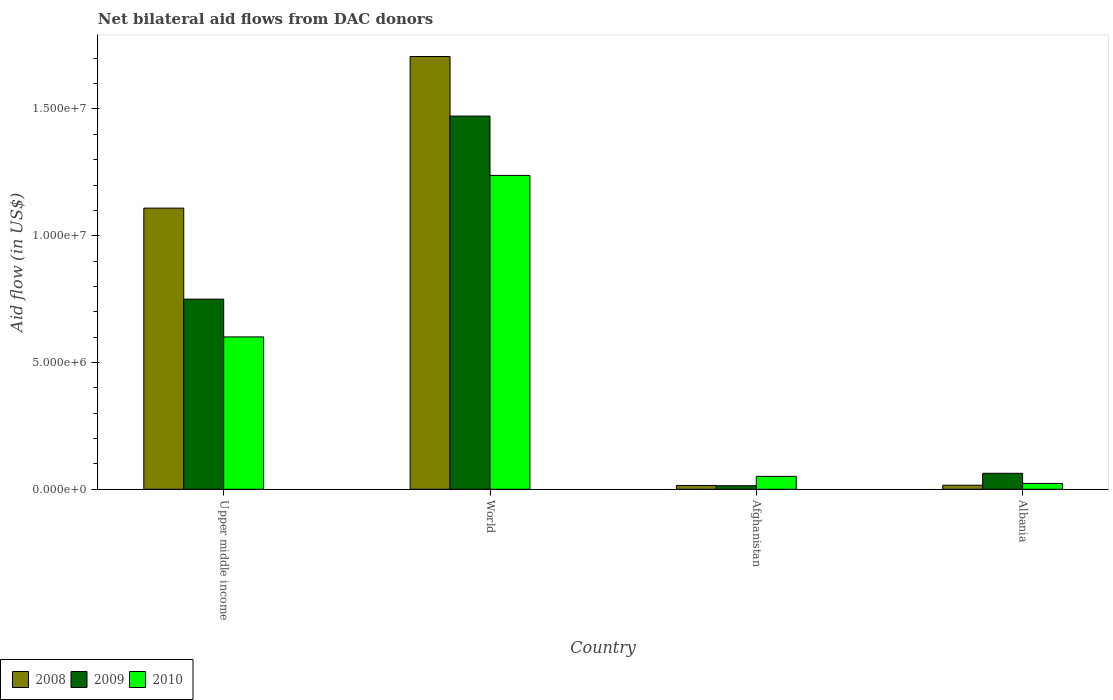How many different coloured bars are there?
Offer a terse response. 3. Are the number of bars per tick equal to the number of legend labels?
Your answer should be very brief. Yes. Are the number of bars on each tick of the X-axis equal?
Offer a very short reply. Yes. How many bars are there on the 2nd tick from the right?
Ensure brevity in your answer.  3. What is the label of the 4th group of bars from the left?
Give a very brief answer. Albania. What is the net bilateral aid flow in 2010 in Upper middle income?
Keep it short and to the point. 6.01e+06. Across all countries, what is the maximum net bilateral aid flow in 2010?
Your response must be concise. 1.24e+07. Across all countries, what is the minimum net bilateral aid flow in 2008?
Make the answer very short. 1.50e+05. In which country was the net bilateral aid flow in 2010 maximum?
Offer a very short reply. World. In which country was the net bilateral aid flow in 2010 minimum?
Provide a short and direct response. Albania. What is the total net bilateral aid flow in 2010 in the graph?
Provide a short and direct response. 1.91e+07. What is the difference between the net bilateral aid flow in 2008 in Afghanistan and that in Upper middle income?
Give a very brief answer. -1.09e+07. What is the difference between the net bilateral aid flow in 2010 in Albania and the net bilateral aid flow in 2009 in Upper middle income?
Provide a short and direct response. -7.27e+06. What is the average net bilateral aid flow in 2009 per country?
Make the answer very short. 5.75e+06. What is the difference between the net bilateral aid flow of/in 2010 and net bilateral aid flow of/in 2008 in World?
Provide a short and direct response. -4.69e+06. What is the ratio of the net bilateral aid flow in 2009 in Albania to that in Upper middle income?
Offer a terse response. 0.08. Is the net bilateral aid flow in 2008 in Afghanistan less than that in Upper middle income?
Keep it short and to the point. Yes. What is the difference between the highest and the second highest net bilateral aid flow in 2008?
Offer a very short reply. 1.69e+07. What is the difference between the highest and the lowest net bilateral aid flow in 2010?
Your answer should be very brief. 1.22e+07. In how many countries, is the net bilateral aid flow in 2009 greater than the average net bilateral aid flow in 2009 taken over all countries?
Ensure brevity in your answer.  2. What does the 3rd bar from the right in World represents?
Make the answer very short. 2008. Is it the case that in every country, the sum of the net bilateral aid flow in 2009 and net bilateral aid flow in 2008 is greater than the net bilateral aid flow in 2010?
Keep it short and to the point. No. Does the graph contain grids?
Your response must be concise. No. What is the title of the graph?
Your answer should be very brief. Net bilateral aid flows from DAC donors. What is the label or title of the X-axis?
Provide a succinct answer. Country. What is the label or title of the Y-axis?
Your response must be concise. Aid flow (in US$). What is the Aid flow (in US$) in 2008 in Upper middle income?
Make the answer very short. 1.11e+07. What is the Aid flow (in US$) in 2009 in Upper middle income?
Give a very brief answer. 7.50e+06. What is the Aid flow (in US$) of 2010 in Upper middle income?
Provide a succinct answer. 6.01e+06. What is the Aid flow (in US$) of 2008 in World?
Your answer should be compact. 1.71e+07. What is the Aid flow (in US$) in 2009 in World?
Your answer should be very brief. 1.47e+07. What is the Aid flow (in US$) of 2010 in World?
Your response must be concise. 1.24e+07. What is the Aid flow (in US$) in 2010 in Afghanistan?
Provide a succinct answer. 5.10e+05. What is the Aid flow (in US$) of 2009 in Albania?
Provide a succinct answer. 6.30e+05. Across all countries, what is the maximum Aid flow (in US$) of 2008?
Provide a succinct answer. 1.71e+07. Across all countries, what is the maximum Aid flow (in US$) of 2009?
Your response must be concise. 1.47e+07. Across all countries, what is the maximum Aid flow (in US$) of 2010?
Keep it short and to the point. 1.24e+07. Across all countries, what is the minimum Aid flow (in US$) of 2008?
Make the answer very short. 1.50e+05. Across all countries, what is the minimum Aid flow (in US$) in 2009?
Provide a short and direct response. 1.40e+05. Across all countries, what is the minimum Aid flow (in US$) of 2010?
Your answer should be compact. 2.30e+05. What is the total Aid flow (in US$) of 2008 in the graph?
Your answer should be compact. 2.85e+07. What is the total Aid flow (in US$) of 2009 in the graph?
Your answer should be compact. 2.30e+07. What is the total Aid flow (in US$) of 2010 in the graph?
Make the answer very short. 1.91e+07. What is the difference between the Aid flow (in US$) in 2008 in Upper middle income and that in World?
Provide a succinct answer. -5.98e+06. What is the difference between the Aid flow (in US$) in 2009 in Upper middle income and that in World?
Provide a short and direct response. -7.22e+06. What is the difference between the Aid flow (in US$) in 2010 in Upper middle income and that in World?
Offer a terse response. -6.37e+06. What is the difference between the Aid flow (in US$) of 2008 in Upper middle income and that in Afghanistan?
Offer a very short reply. 1.09e+07. What is the difference between the Aid flow (in US$) of 2009 in Upper middle income and that in Afghanistan?
Make the answer very short. 7.36e+06. What is the difference between the Aid flow (in US$) of 2010 in Upper middle income and that in Afghanistan?
Provide a short and direct response. 5.50e+06. What is the difference between the Aid flow (in US$) of 2008 in Upper middle income and that in Albania?
Ensure brevity in your answer.  1.09e+07. What is the difference between the Aid flow (in US$) in 2009 in Upper middle income and that in Albania?
Your answer should be compact. 6.87e+06. What is the difference between the Aid flow (in US$) of 2010 in Upper middle income and that in Albania?
Your answer should be very brief. 5.78e+06. What is the difference between the Aid flow (in US$) of 2008 in World and that in Afghanistan?
Your answer should be compact. 1.69e+07. What is the difference between the Aid flow (in US$) of 2009 in World and that in Afghanistan?
Provide a short and direct response. 1.46e+07. What is the difference between the Aid flow (in US$) in 2010 in World and that in Afghanistan?
Offer a terse response. 1.19e+07. What is the difference between the Aid flow (in US$) of 2008 in World and that in Albania?
Your response must be concise. 1.69e+07. What is the difference between the Aid flow (in US$) of 2009 in World and that in Albania?
Offer a terse response. 1.41e+07. What is the difference between the Aid flow (in US$) in 2010 in World and that in Albania?
Make the answer very short. 1.22e+07. What is the difference between the Aid flow (in US$) in 2008 in Afghanistan and that in Albania?
Your response must be concise. -10000. What is the difference between the Aid flow (in US$) in 2009 in Afghanistan and that in Albania?
Your answer should be very brief. -4.90e+05. What is the difference between the Aid flow (in US$) of 2010 in Afghanistan and that in Albania?
Your answer should be compact. 2.80e+05. What is the difference between the Aid flow (in US$) in 2008 in Upper middle income and the Aid flow (in US$) in 2009 in World?
Offer a terse response. -3.63e+06. What is the difference between the Aid flow (in US$) of 2008 in Upper middle income and the Aid flow (in US$) of 2010 in World?
Offer a very short reply. -1.29e+06. What is the difference between the Aid flow (in US$) in 2009 in Upper middle income and the Aid flow (in US$) in 2010 in World?
Provide a short and direct response. -4.88e+06. What is the difference between the Aid flow (in US$) of 2008 in Upper middle income and the Aid flow (in US$) of 2009 in Afghanistan?
Make the answer very short. 1.10e+07. What is the difference between the Aid flow (in US$) in 2008 in Upper middle income and the Aid flow (in US$) in 2010 in Afghanistan?
Keep it short and to the point. 1.06e+07. What is the difference between the Aid flow (in US$) of 2009 in Upper middle income and the Aid flow (in US$) of 2010 in Afghanistan?
Your response must be concise. 6.99e+06. What is the difference between the Aid flow (in US$) of 2008 in Upper middle income and the Aid flow (in US$) of 2009 in Albania?
Your answer should be compact. 1.05e+07. What is the difference between the Aid flow (in US$) in 2008 in Upper middle income and the Aid flow (in US$) in 2010 in Albania?
Provide a short and direct response. 1.09e+07. What is the difference between the Aid flow (in US$) in 2009 in Upper middle income and the Aid flow (in US$) in 2010 in Albania?
Provide a short and direct response. 7.27e+06. What is the difference between the Aid flow (in US$) of 2008 in World and the Aid flow (in US$) of 2009 in Afghanistan?
Your answer should be very brief. 1.69e+07. What is the difference between the Aid flow (in US$) of 2008 in World and the Aid flow (in US$) of 2010 in Afghanistan?
Your answer should be very brief. 1.66e+07. What is the difference between the Aid flow (in US$) in 2009 in World and the Aid flow (in US$) in 2010 in Afghanistan?
Provide a short and direct response. 1.42e+07. What is the difference between the Aid flow (in US$) in 2008 in World and the Aid flow (in US$) in 2009 in Albania?
Your answer should be very brief. 1.64e+07. What is the difference between the Aid flow (in US$) in 2008 in World and the Aid flow (in US$) in 2010 in Albania?
Provide a short and direct response. 1.68e+07. What is the difference between the Aid flow (in US$) of 2009 in World and the Aid flow (in US$) of 2010 in Albania?
Provide a succinct answer. 1.45e+07. What is the difference between the Aid flow (in US$) of 2008 in Afghanistan and the Aid flow (in US$) of 2009 in Albania?
Provide a succinct answer. -4.80e+05. What is the difference between the Aid flow (in US$) of 2008 in Afghanistan and the Aid flow (in US$) of 2010 in Albania?
Your response must be concise. -8.00e+04. What is the difference between the Aid flow (in US$) of 2009 in Afghanistan and the Aid flow (in US$) of 2010 in Albania?
Ensure brevity in your answer.  -9.00e+04. What is the average Aid flow (in US$) in 2008 per country?
Provide a succinct answer. 7.12e+06. What is the average Aid flow (in US$) in 2009 per country?
Make the answer very short. 5.75e+06. What is the average Aid flow (in US$) in 2010 per country?
Your answer should be very brief. 4.78e+06. What is the difference between the Aid flow (in US$) of 2008 and Aid flow (in US$) of 2009 in Upper middle income?
Provide a succinct answer. 3.59e+06. What is the difference between the Aid flow (in US$) in 2008 and Aid flow (in US$) in 2010 in Upper middle income?
Give a very brief answer. 5.08e+06. What is the difference between the Aid flow (in US$) in 2009 and Aid flow (in US$) in 2010 in Upper middle income?
Your answer should be very brief. 1.49e+06. What is the difference between the Aid flow (in US$) in 2008 and Aid flow (in US$) in 2009 in World?
Offer a terse response. 2.35e+06. What is the difference between the Aid flow (in US$) of 2008 and Aid flow (in US$) of 2010 in World?
Give a very brief answer. 4.69e+06. What is the difference between the Aid flow (in US$) of 2009 and Aid flow (in US$) of 2010 in World?
Offer a very short reply. 2.34e+06. What is the difference between the Aid flow (in US$) in 2008 and Aid flow (in US$) in 2009 in Afghanistan?
Your response must be concise. 10000. What is the difference between the Aid flow (in US$) of 2008 and Aid flow (in US$) of 2010 in Afghanistan?
Give a very brief answer. -3.60e+05. What is the difference between the Aid flow (in US$) in 2009 and Aid flow (in US$) in 2010 in Afghanistan?
Provide a short and direct response. -3.70e+05. What is the difference between the Aid flow (in US$) of 2008 and Aid flow (in US$) of 2009 in Albania?
Offer a terse response. -4.70e+05. What is the difference between the Aid flow (in US$) in 2008 and Aid flow (in US$) in 2010 in Albania?
Make the answer very short. -7.00e+04. What is the difference between the Aid flow (in US$) of 2009 and Aid flow (in US$) of 2010 in Albania?
Ensure brevity in your answer.  4.00e+05. What is the ratio of the Aid flow (in US$) in 2008 in Upper middle income to that in World?
Your answer should be compact. 0.65. What is the ratio of the Aid flow (in US$) in 2009 in Upper middle income to that in World?
Ensure brevity in your answer.  0.51. What is the ratio of the Aid flow (in US$) in 2010 in Upper middle income to that in World?
Provide a succinct answer. 0.49. What is the ratio of the Aid flow (in US$) in 2008 in Upper middle income to that in Afghanistan?
Your response must be concise. 73.93. What is the ratio of the Aid flow (in US$) of 2009 in Upper middle income to that in Afghanistan?
Offer a terse response. 53.57. What is the ratio of the Aid flow (in US$) of 2010 in Upper middle income to that in Afghanistan?
Give a very brief answer. 11.78. What is the ratio of the Aid flow (in US$) in 2008 in Upper middle income to that in Albania?
Your answer should be compact. 69.31. What is the ratio of the Aid flow (in US$) of 2009 in Upper middle income to that in Albania?
Make the answer very short. 11.9. What is the ratio of the Aid flow (in US$) in 2010 in Upper middle income to that in Albania?
Your answer should be very brief. 26.13. What is the ratio of the Aid flow (in US$) in 2008 in World to that in Afghanistan?
Your answer should be compact. 113.8. What is the ratio of the Aid flow (in US$) of 2009 in World to that in Afghanistan?
Ensure brevity in your answer.  105.14. What is the ratio of the Aid flow (in US$) in 2010 in World to that in Afghanistan?
Give a very brief answer. 24.27. What is the ratio of the Aid flow (in US$) in 2008 in World to that in Albania?
Provide a succinct answer. 106.69. What is the ratio of the Aid flow (in US$) in 2009 in World to that in Albania?
Your response must be concise. 23.37. What is the ratio of the Aid flow (in US$) in 2010 in World to that in Albania?
Give a very brief answer. 53.83. What is the ratio of the Aid flow (in US$) of 2008 in Afghanistan to that in Albania?
Give a very brief answer. 0.94. What is the ratio of the Aid flow (in US$) of 2009 in Afghanistan to that in Albania?
Make the answer very short. 0.22. What is the ratio of the Aid flow (in US$) of 2010 in Afghanistan to that in Albania?
Provide a succinct answer. 2.22. What is the difference between the highest and the second highest Aid flow (in US$) of 2008?
Keep it short and to the point. 5.98e+06. What is the difference between the highest and the second highest Aid flow (in US$) in 2009?
Provide a short and direct response. 7.22e+06. What is the difference between the highest and the second highest Aid flow (in US$) in 2010?
Your response must be concise. 6.37e+06. What is the difference between the highest and the lowest Aid flow (in US$) of 2008?
Provide a short and direct response. 1.69e+07. What is the difference between the highest and the lowest Aid flow (in US$) in 2009?
Your response must be concise. 1.46e+07. What is the difference between the highest and the lowest Aid flow (in US$) in 2010?
Give a very brief answer. 1.22e+07. 